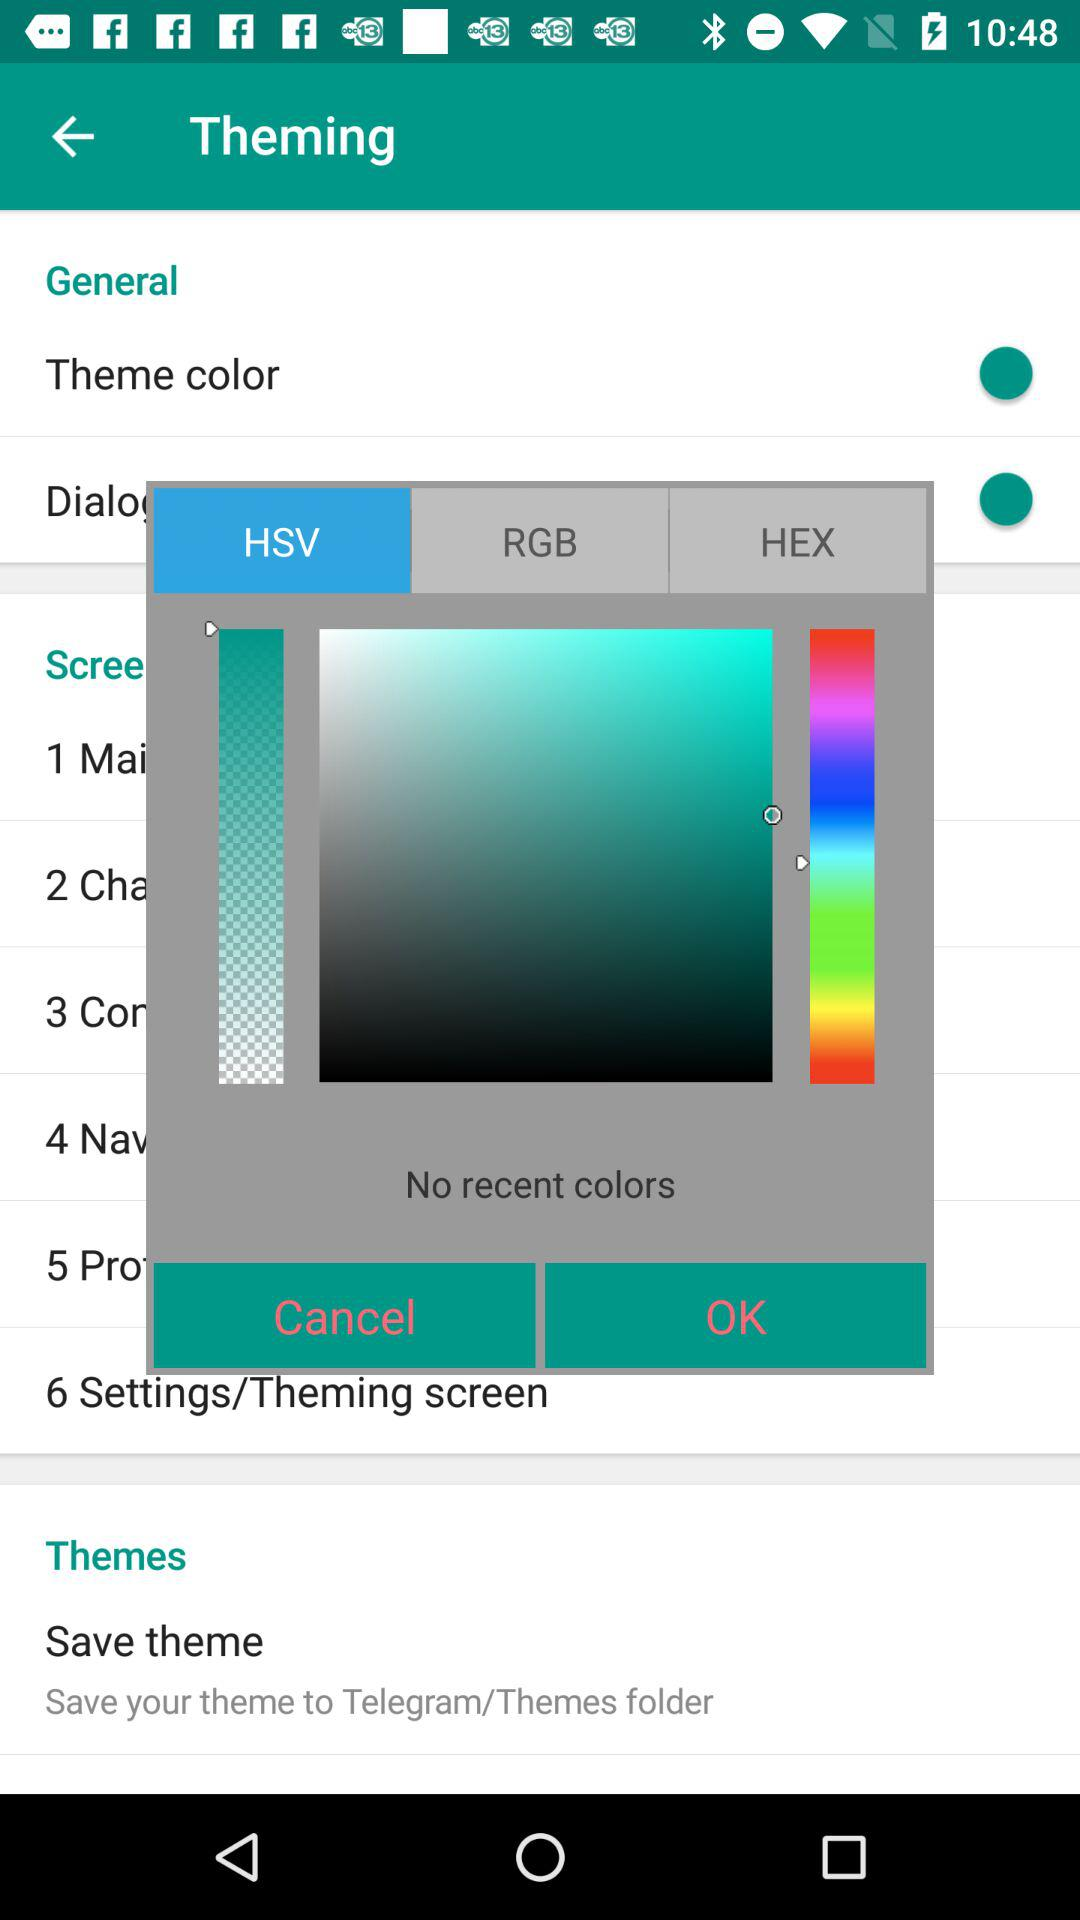How many colors are there in the rainbow gradient?
Answer the question using a single word or phrase. 7 